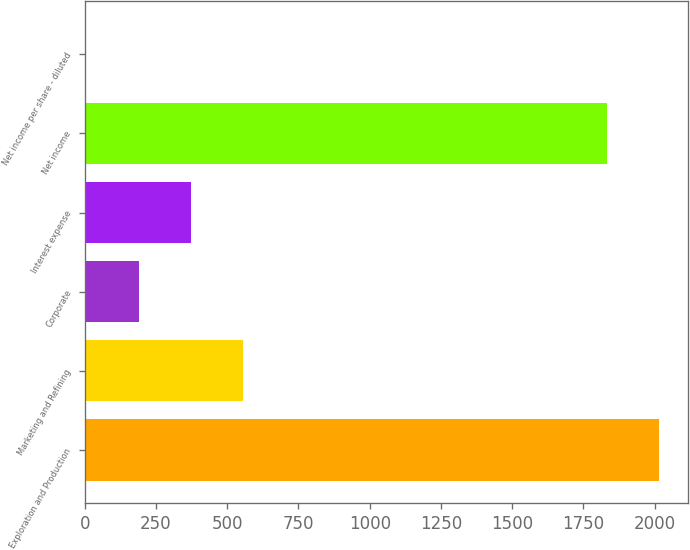<chart> <loc_0><loc_0><loc_500><loc_500><bar_chart><fcel>Exploration and Production<fcel>Marketing and Refining<fcel>Corporate<fcel>Interest expense<fcel>Net income<fcel>Net income per share - diluted<nl><fcel>2015.63<fcel>556.63<fcel>189.37<fcel>373<fcel>1832<fcel>5.74<nl></chart> 